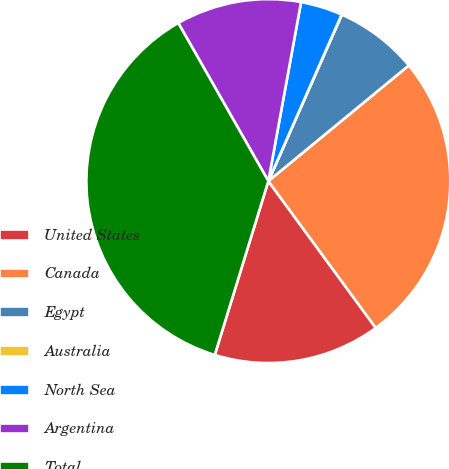Convert chart. <chart><loc_0><loc_0><loc_500><loc_500><pie_chart><fcel>United States<fcel>Canada<fcel>Egypt<fcel>Australia<fcel>North Sea<fcel>Argentina<fcel>Total<nl><fcel>14.81%<fcel>25.91%<fcel>7.42%<fcel>0.02%<fcel>3.72%<fcel>11.12%<fcel>37.0%<nl></chart> 